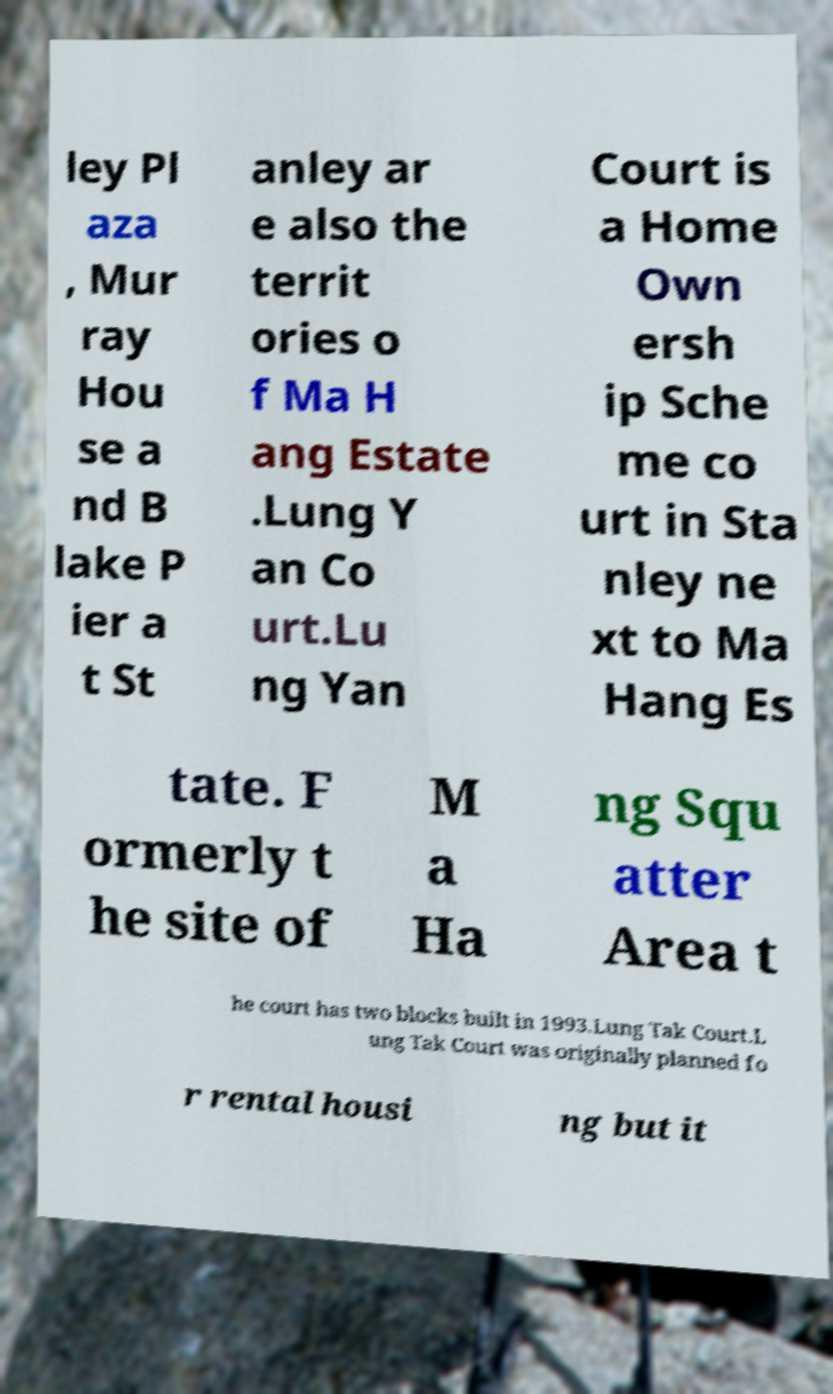There's text embedded in this image that I need extracted. Can you transcribe it verbatim? ley Pl aza , Mur ray Hou se a nd B lake P ier a t St anley ar e also the territ ories o f Ma H ang Estate .Lung Y an Co urt.Lu ng Yan Court is a Home Own ersh ip Sche me co urt in Sta nley ne xt to Ma Hang Es tate. F ormerly t he site of M a Ha ng Squ atter Area t he court has two blocks built in 1993.Lung Tak Court.L ung Tak Court was originally planned fo r rental housi ng but it 